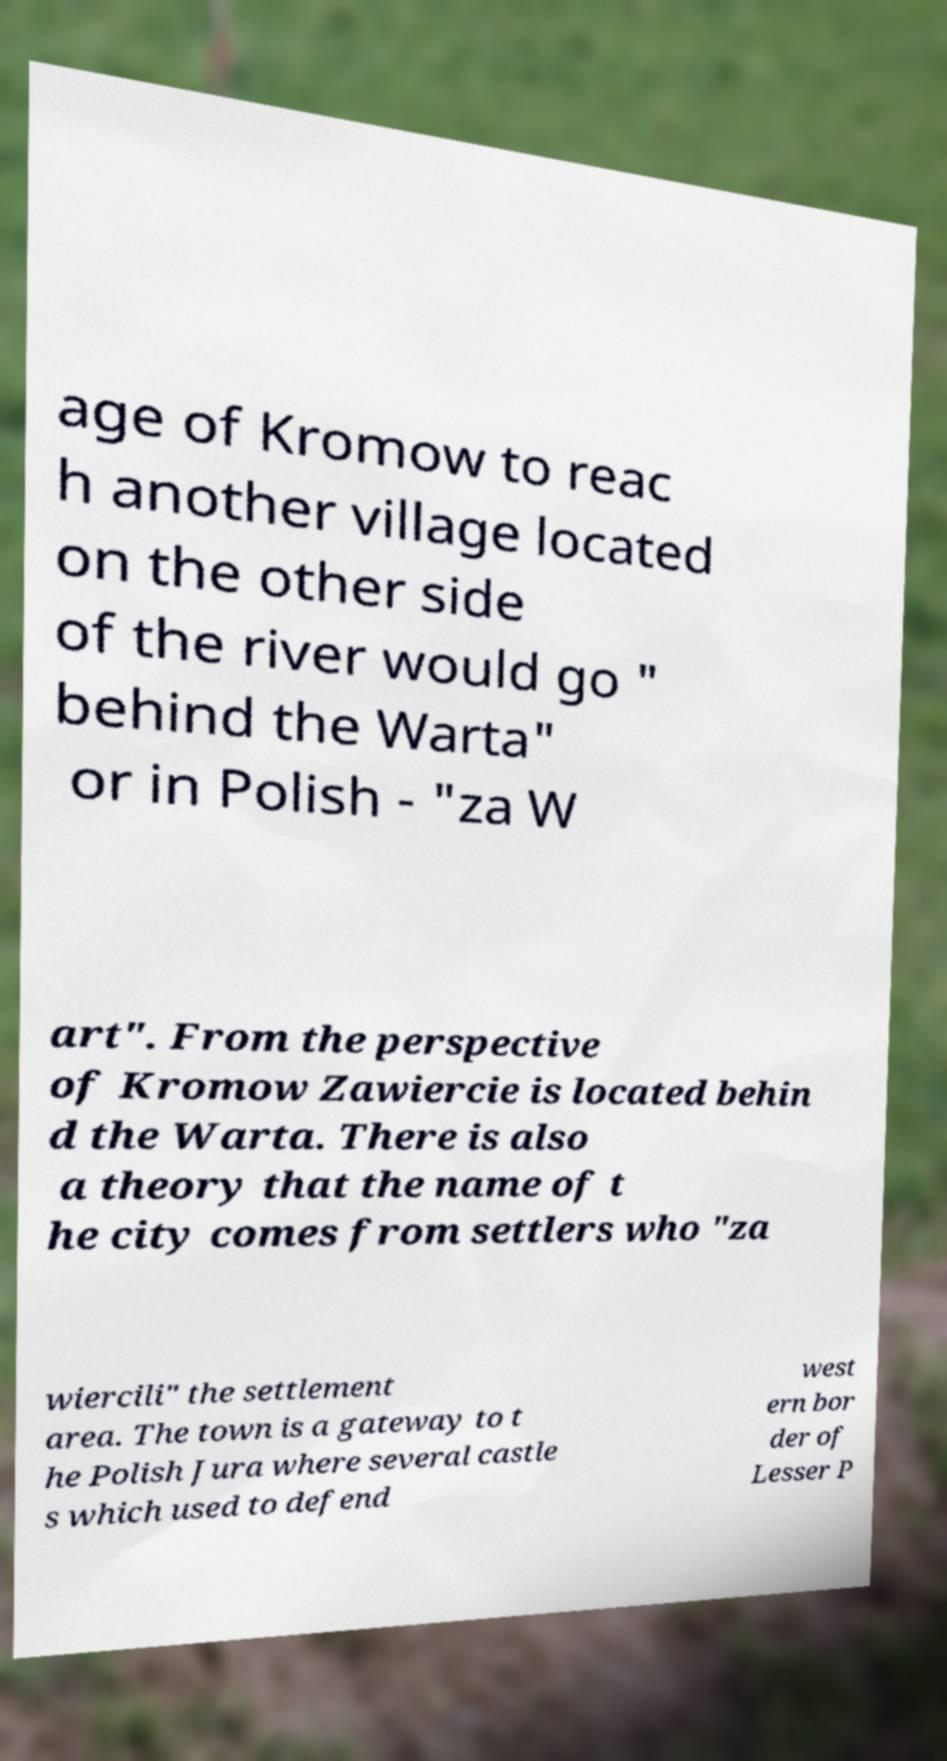For documentation purposes, I need the text within this image transcribed. Could you provide that? age of Kromow to reac h another village located on the other side of the river would go " behind the Warta" or in Polish - "za W art". From the perspective of Kromow Zawiercie is located behin d the Warta. There is also a theory that the name of t he city comes from settlers who "za wiercili" the settlement area. The town is a gateway to t he Polish Jura where several castle s which used to defend west ern bor der of Lesser P 